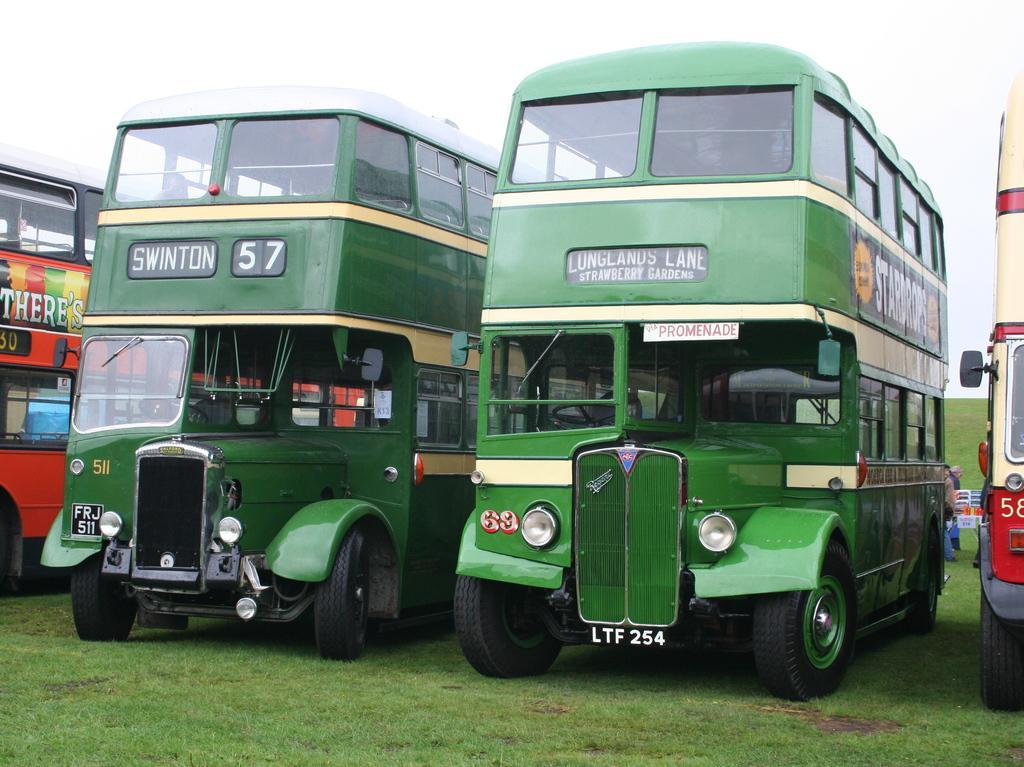Please provide a concise description of this image. In this image, I can see three double-decker buses, which are parked. Here is the grass. These two buses look green in color. In the background, I can see a person standing. On the right side of the image. I can see another double-decker bus. 